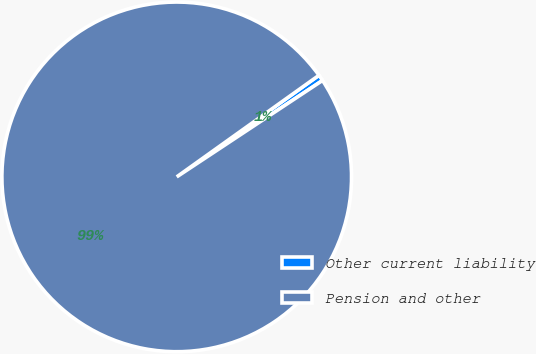Convert chart to OTSL. <chart><loc_0><loc_0><loc_500><loc_500><pie_chart><fcel>Other current liability<fcel>Pension and other<nl><fcel>0.57%<fcel>99.43%<nl></chart> 